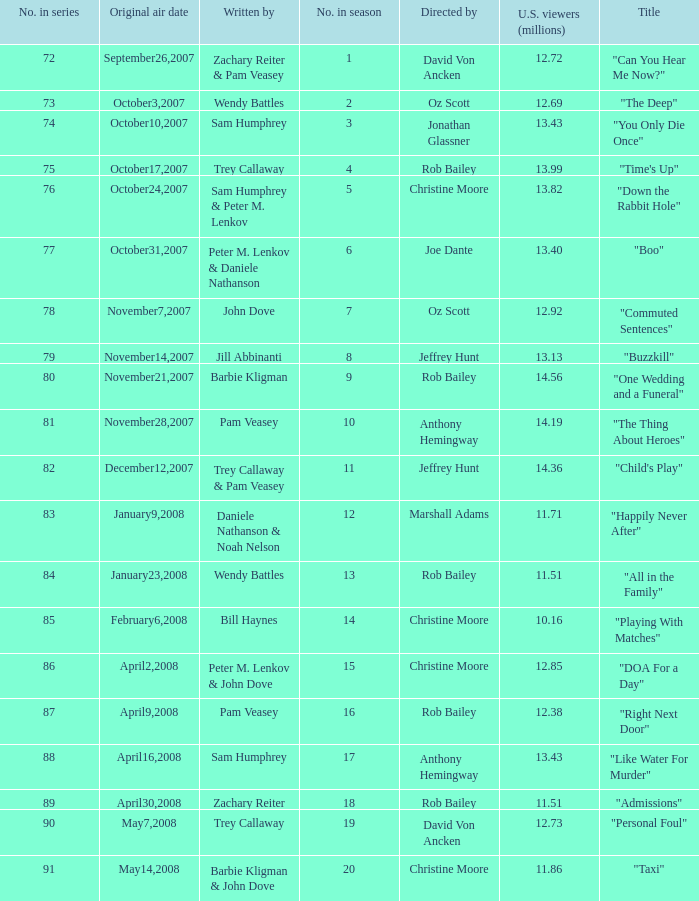How many millions of U.S. viewers watched the episode directed by Rob Bailey and written by Pam Veasey? 12.38. 